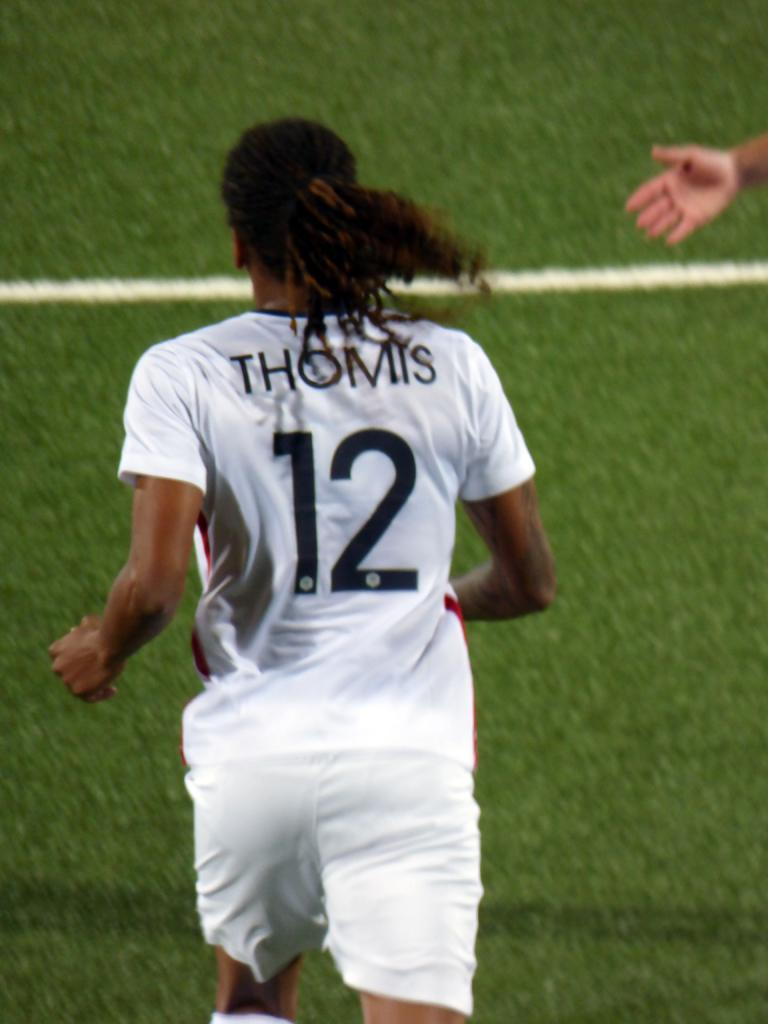<image>
Summarize the visual content of the image. Soccer player number 12 on the field is Thomis. 